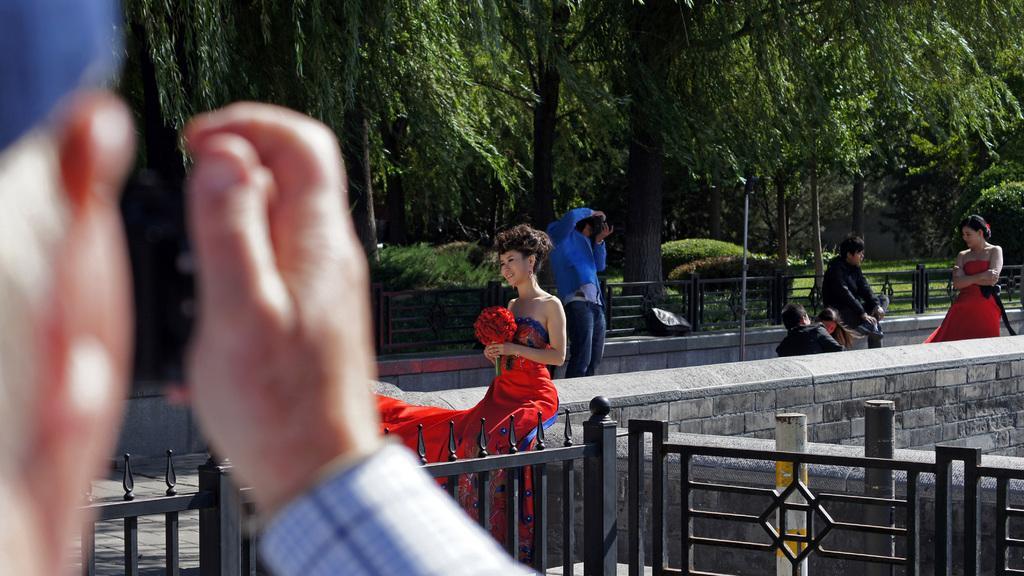Please provide a concise description of this image. In this picture there is a woman who is wearing a red dress and holding the roses. She is sitting on the wall. On the right there is another woman who is also wearing dress and he is standing near to the wall. In front of her i can see two persons are holding the camera. Beside them there is a man who is wearing black dress and he is sitting on the chair. In the background i can see the fencing, light, pole, plants, grass and trees. On the left there is an old man who is also holding a camera. 